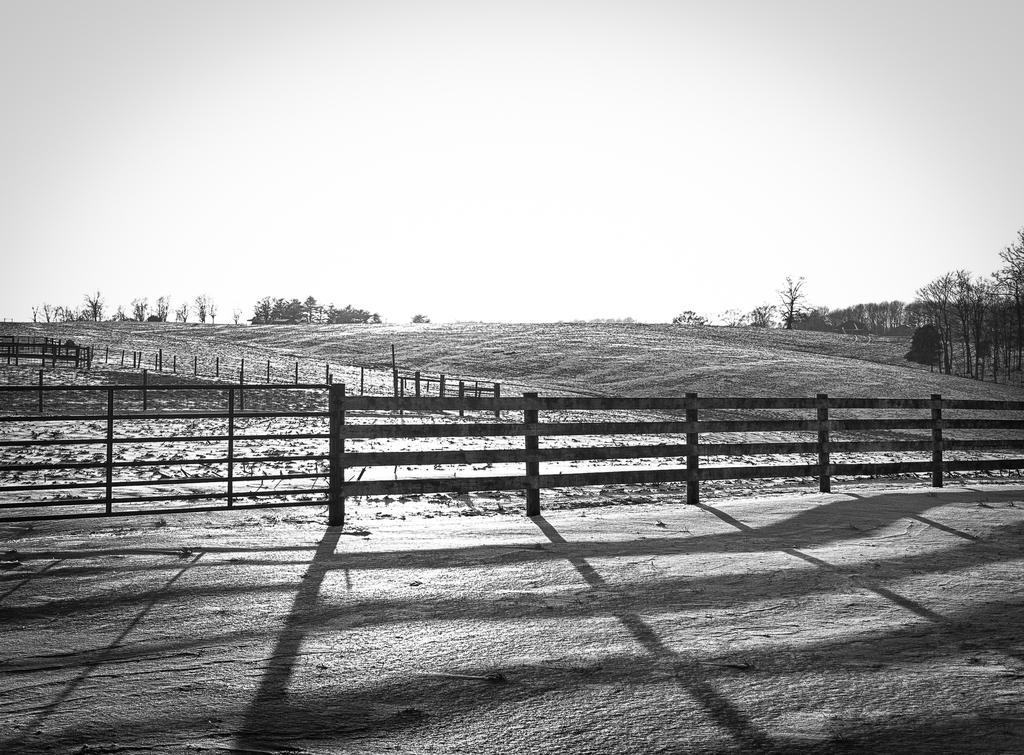In one or two sentences, can you explain what this image depicts? It is an black and white picture. In the front of the image I can see a railing. In the background of the image there are trees, wooden objects and sky. 